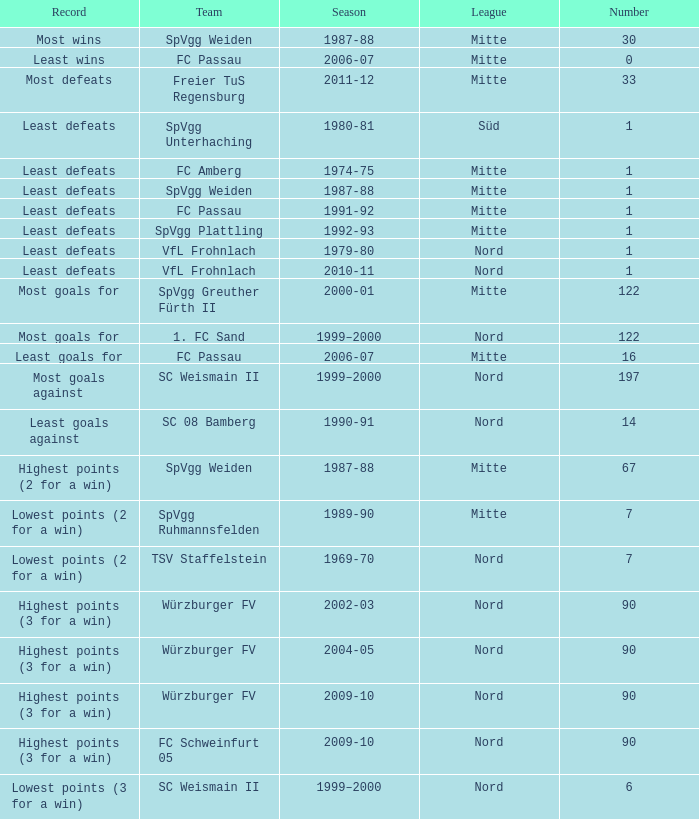What league has a number less than 122, and least wins as the record? Mitte. 